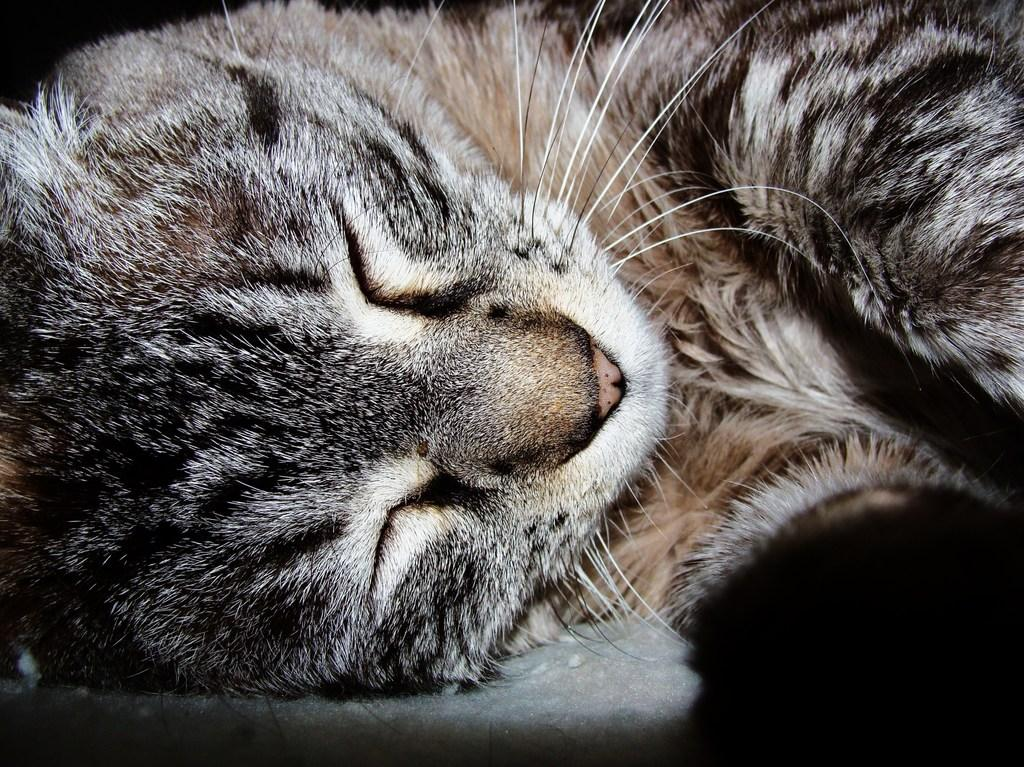What type of creature is present in the image? There is an animal in the image. Can you describe the animal's location in the image? The animal is on the surface. What type of party is the animal attending in the image? There is no party present in the image, and the animal's activities are not mentioned. 